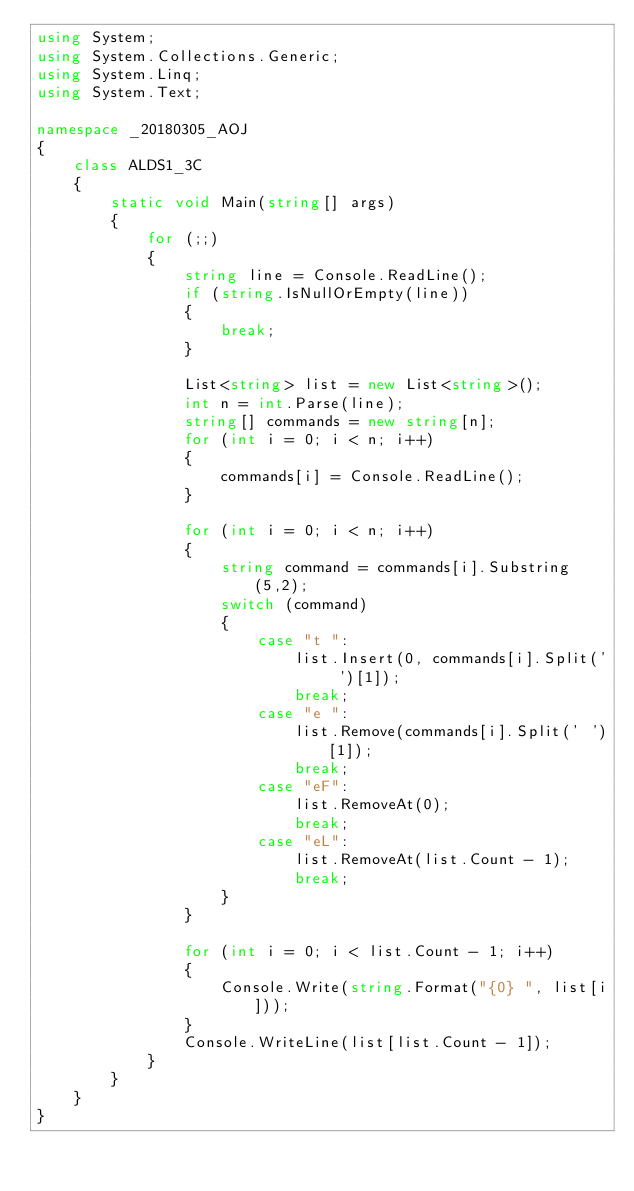Convert code to text. <code><loc_0><loc_0><loc_500><loc_500><_C#_>using System;
using System.Collections.Generic;
using System.Linq;
using System.Text;

namespace _20180305_AOJ
{
    class ALDS1_3C
    {
        static void Main(string[] args)
        {
            for (;;)
            {
                string line = Console.ReadLine();
                if (string.IsNullOrEmpty(line))
                {
                    break;
                }

                List<string> list = new List<string>();
                int n = int.Parse(line);
                string[] commands = new string[n];
                for (int i = 0; i < n; i++)
                {
                    commands[i] = Console.ReadLine();
                }

                for (int i = 0; i < n; i++)
                {
                    string command = commands[i].Substring(5,2);
                    switch (command)
                    {
                        case "t ":
                            list.Insert(0, commands[i].Split(' ')[1]);
                            break;
                        case "e ":
                            list.Remove(commands[i].Split(' ')[1]);
                            break;
                        case "eF":
                            list.RemoveAt(0);
                            break;
                        case "eL":
                            list.RemoveAt(list.Count - 1);
                            break;
                    }
                }

                for (int i = 0; i < list.Count - 1; i++)
                {
                    Console.Write(string.Format("{0} ", list[i]));
                }
                Console.WriteLine(list[list.Count - 1]);
            }
        }
    }
}

</code> 